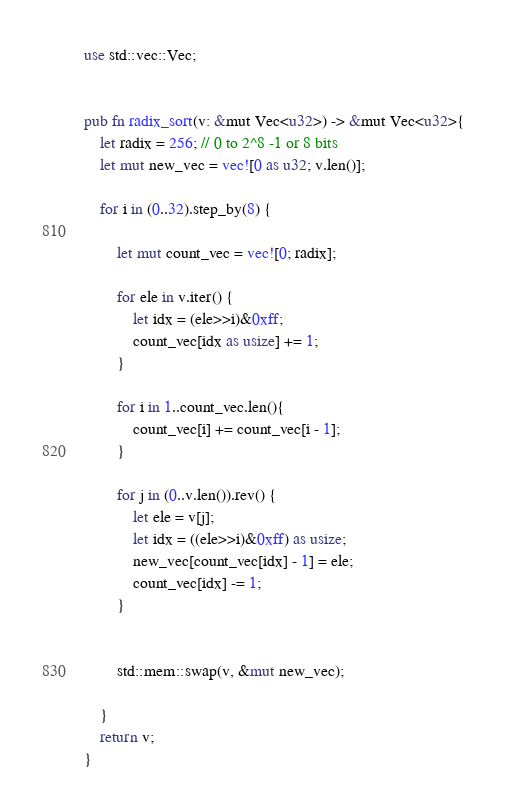<code> <loc_0><loc_0><loc_500><loc_500><_Rust_>use std::vec::Vec;


pub fn radix_sort(v: &mut Vec<u32>) -> &mut Vec<u32>{
    let radix = 256; // 0 to 2^8 -1 or 8 bits
    let mut new_vec = vec![0 as u32; v.len()];

    for i in (0..32).step_by(8) {

        let mut count_vec = vec![0; radix];  

        for ele in v.iter() {
            let idx = (ele>>i)&0xff;
            count_vec[idx as usize] += 1;
        } 

        for i in 1..count_vec.len(){
            count_vec[i] += count_vec[i - 1];
        }
        
        for j in (0..v.len()).rev() {
            let ele = v[j];
            let idx = ((ele>>i)&0xff) as usize;
            new_vec[count_vec[idx] - 1] = ele;
            count_vec[idx] -= 1;
        }


        std::mem::swap(v, &mut new_vec);

    }
    return v;
}
</code> 